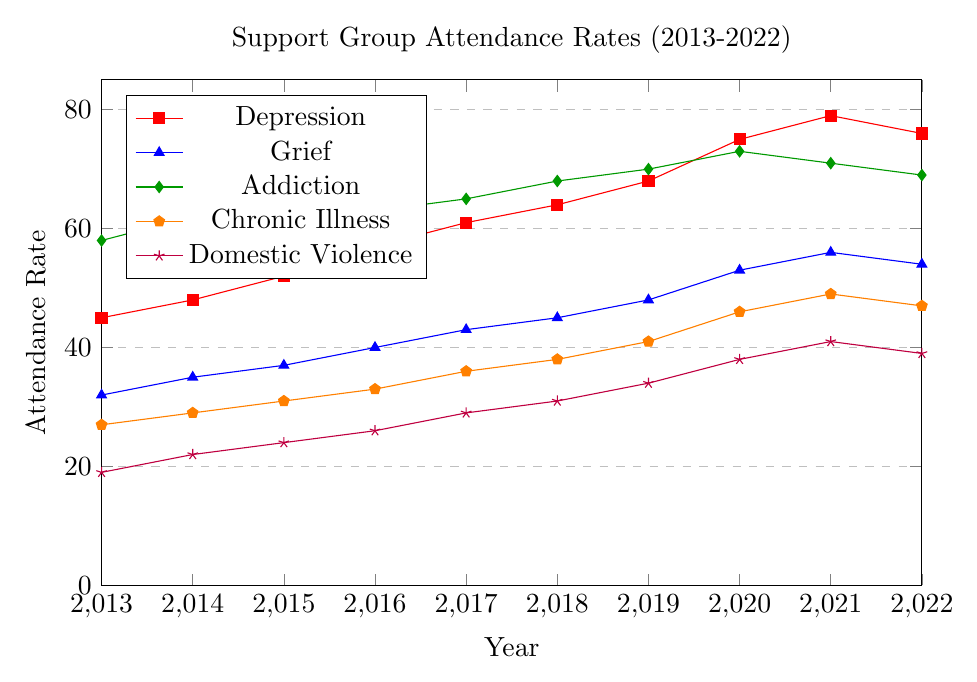Which support group had the highest attendance rate in 2022? To find the answer, look at the attendance rates for each support group in 2022. The group with the highest value is "Depression" at 76.
Answer: Depression Did any group experience a decline in attendance rate from 2021 to 2022? If so, which one? Check the attendance rates for each group in 2021 and 2022. The groups that experienced a decline are "Depression" (79 to 76), "Grief" (56 to 54), and "Addiction" (71 to 69).
Answer: Depression, Grief, Addiction Which group had the smallest increase in attendance rate over the 10-year period from 2013 to 2022? Calculate the increase for each group by subtracting the 2013 rate from the 2022 rate. "Depression" increased by 31, "Grief" by 22, "Addiction" by 11, "Chronic Illness" by 20, and "Domestic Violence" by 20. The smallest increase is for "Addiction".
Answer: Addiction What was the attendance rate for the "Chronic Illness" group in 2020, and how did it change by 2022? Note the attendance rate for "Chronic Illness" in 2020 (46) and in 2022 (47). The change is calculated by subtracting the 2020 rate from the 2022 rate, which results in an increase of 1.
Answer: 46 in 2020, increased by 1 to 47 in 2022 Which two groups had the largest gap in attendance rate in any given year within the time span? Compare the attendance rates for all pairs of groups in each year (2013-2022). The largest gap in any single year is between "Addiction" (58) and "Domestic Violence" (19) in 2013, which is a gap of 39.
Answer: Addiction and Domestic Violence in 2013 What was the average attendance rate for the "Depression" group over the 10 years? Add up all the attendance rates for the "Depression" group from 2013 to 2022, then divide by the number of years. The sum is 625, and there are 10 years, so the average is 625/10 = 62.5.
Answer: 62.5 In which year did the "Grief" support group see the largest single-year increase in attendance rate, and what was the increase? Calculate the differences in attendance rates year-to-year for "Grief" from 2013 to 2022. The largest increase occurred from 2019 (48) to 2020 (53), which is an increase of 5.
Answer: 2020, increased by 5 How does the trend in attendance rates for "Domestic Violence" compare to "Addiction" from 2013 to 2022? Observe the trend lines for both groups. "Domestic Violence" shows a steady increase while "Addiction" fluctuates but generally follows an increasing trend until it declines after 2020.
Answer: Steady increase for Domestic Violence, fluctuating for Addiction By how much did the attendance rate for "Depression" change from the first year to the last year? Calculate the change by subtracting the 2013 rate from the 2022 rate for "Depression" (76 - 45). The change is 31.
Answer: Increased by 31 What year did the "Addiction" group reach its peak attendance rate, and what was the rate? Identify the highest point on the "Addiction" line, which is in 2020 with an attendance rate of 73.
Answer: 2020, with 73 